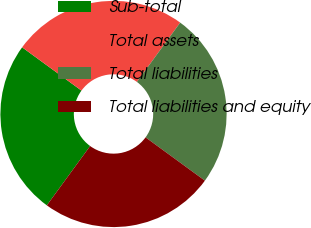<chart> <loc_0><loc_0><loc_500><loc_500><pie_chart><fcel>Sub-total<fcel>Total assets<fcel>Total liabilities<fcel>Total liabilities and equity<nl><fcel>25.0%<fcel>25.0%<fcel>25.0%<fcel>25.0%<nl></chart> 